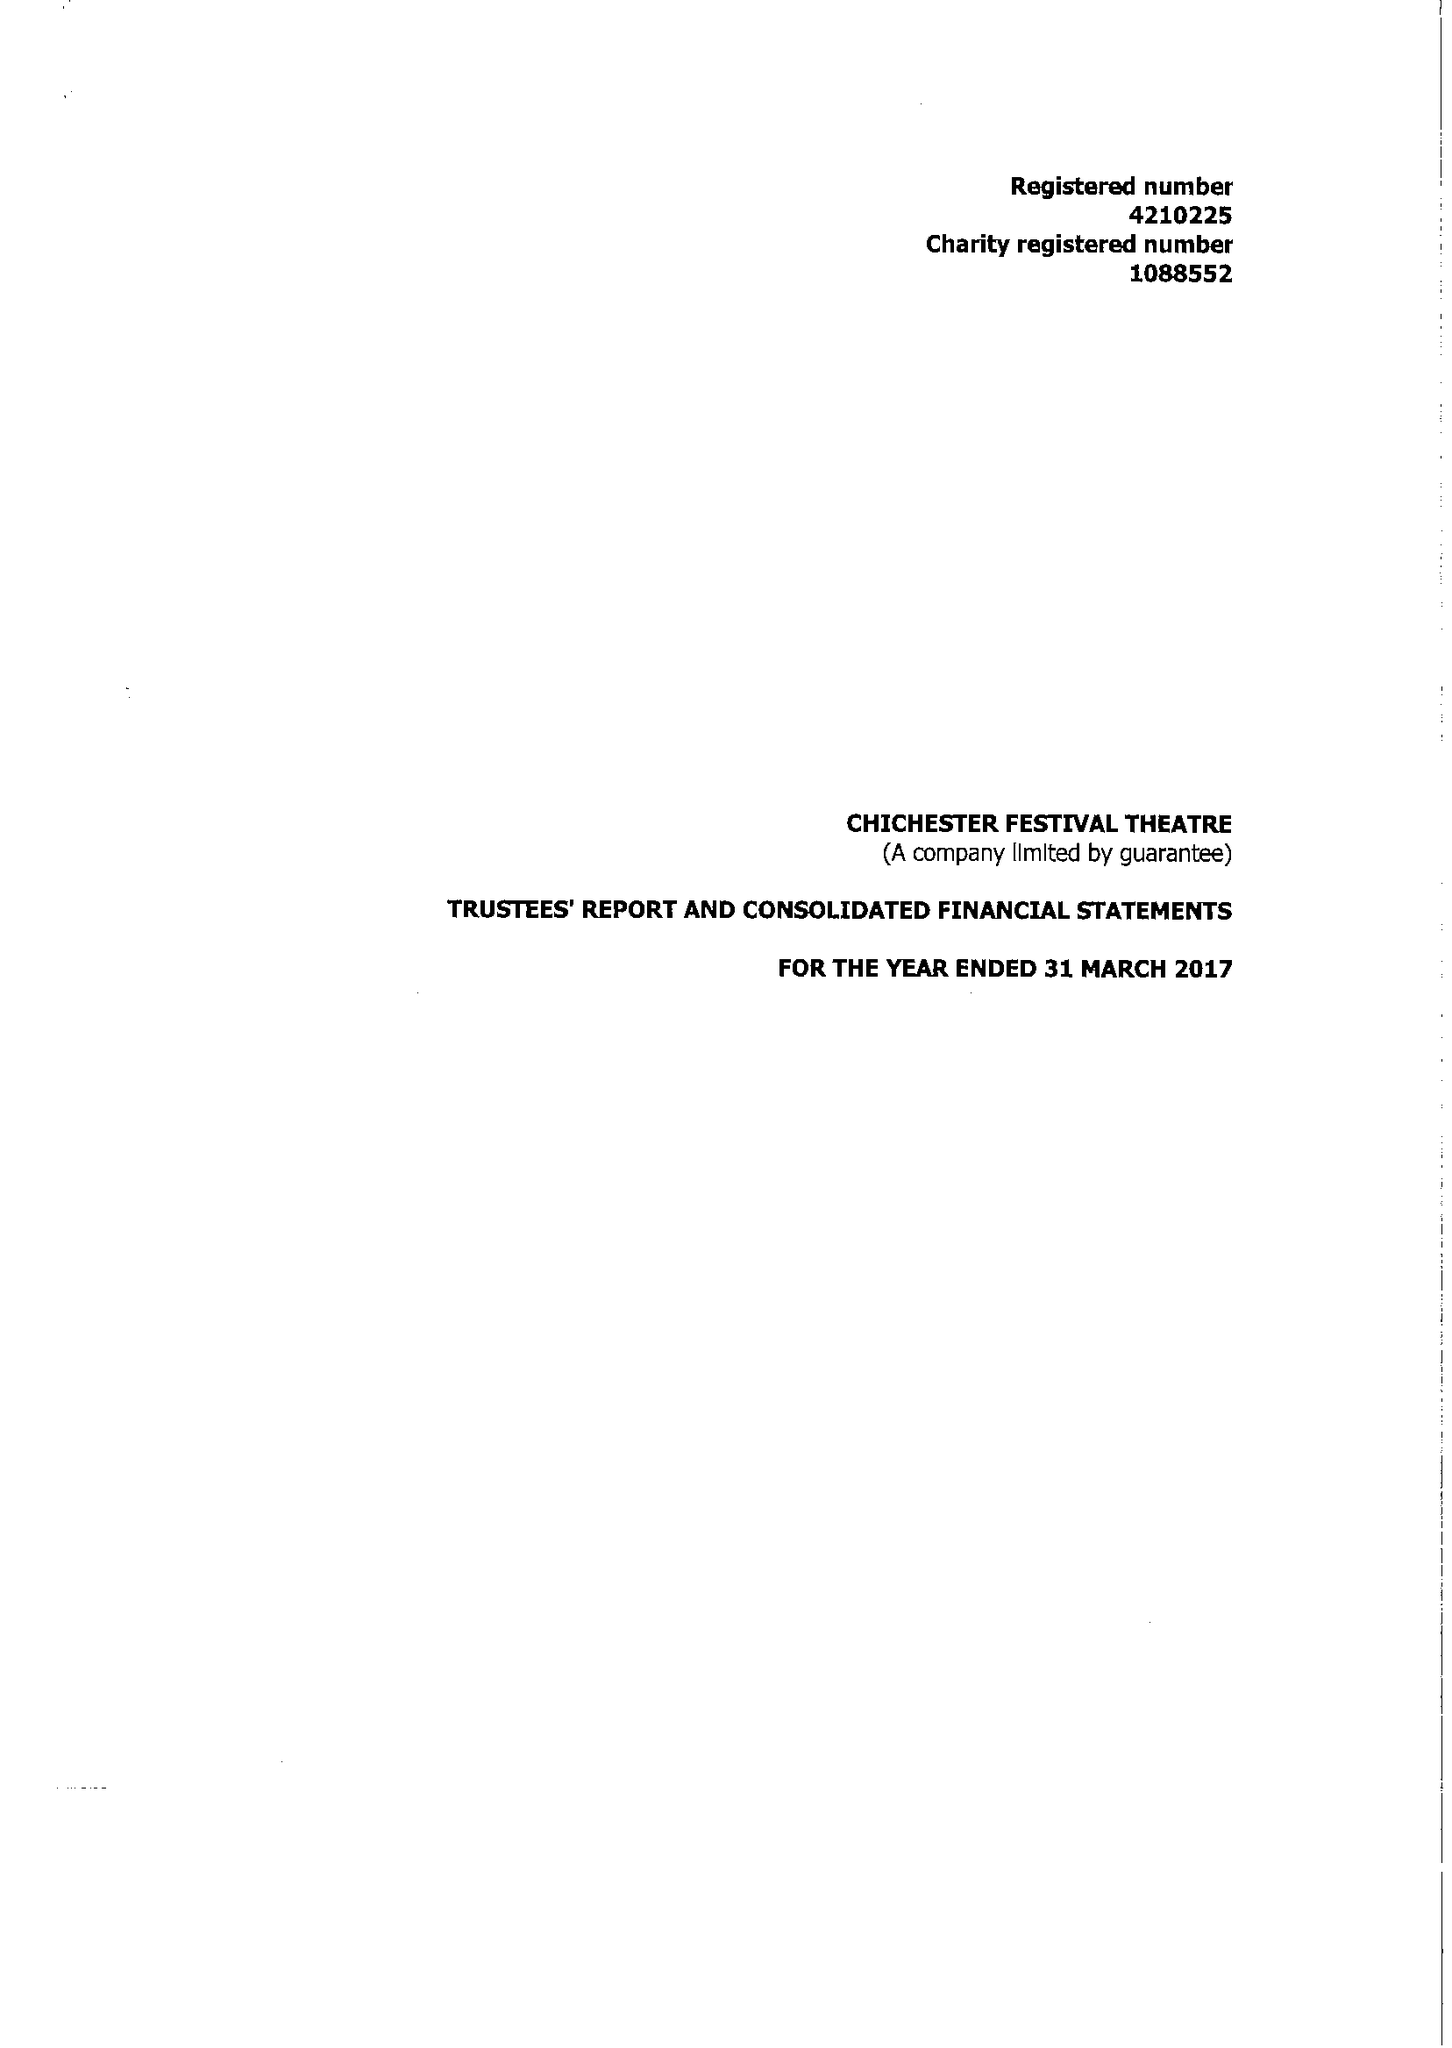What is the value for the address__postcode?
Answer the question using a single word or phrase. PO19 6AP 